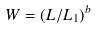Convert formula to latex. <formula><loc_0><loc_0><loc_500><loc_500>W = ( L / L _ { 1 } ) ^ { b }</formula> 